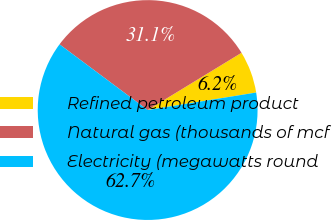Convert chart to OTSL. <chart><loc_0><loc_0><loc_500><loc_500><pie_chart><fcel>Refined petroleum product<fcel>Natural gas (thousands of mcf<fcel>Electricity (megawatts round<nl><fcel>6.17%<fcel>31.09%<fcel>62.75%<nl></chart> 